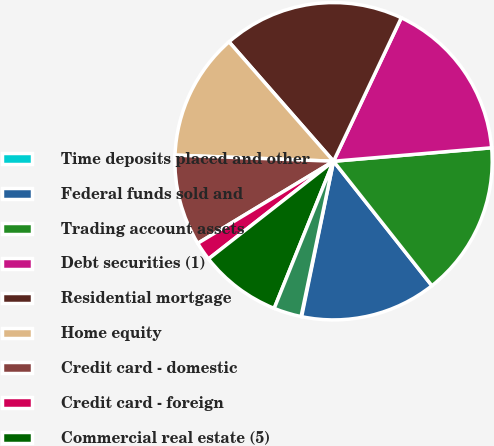Convert chart to OTSL. <chart><loc_0><loc_0><loc_500><loc_500><pie_chart><fcel>Time deposits placed and other<fcel>Federal funds sold and<fcel>Trading account assets<fcel>Debt securities (1)<fcel>Residential mortgage<fcel>Home equity<fcel>Credit card - domestic<fcel>Credit card - foreign<fcel>Commercial real estate (5)<fcel>Commercial lease financing<nl><fcel>0.06%<fcel>13.86%<fcel>15.7%<fcel>16.62%<fcel>18.46%<fcel>12.94%<fcel>9.26%<fcel>1.9%<fcel>8.34%<fcel>2.82%<nl></chart> 